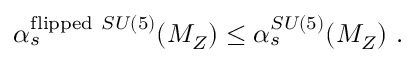<formula> <loc_0><loc_0><loc_500><loc_500>\alpha _ { s } ^ { f l i p p e d S U ( 5 ) } ( M _ { Z } ) \leq \alpha _ { s } ^ { S U ( 5 ) } ( M _ { Z } ) \ .</formula> 